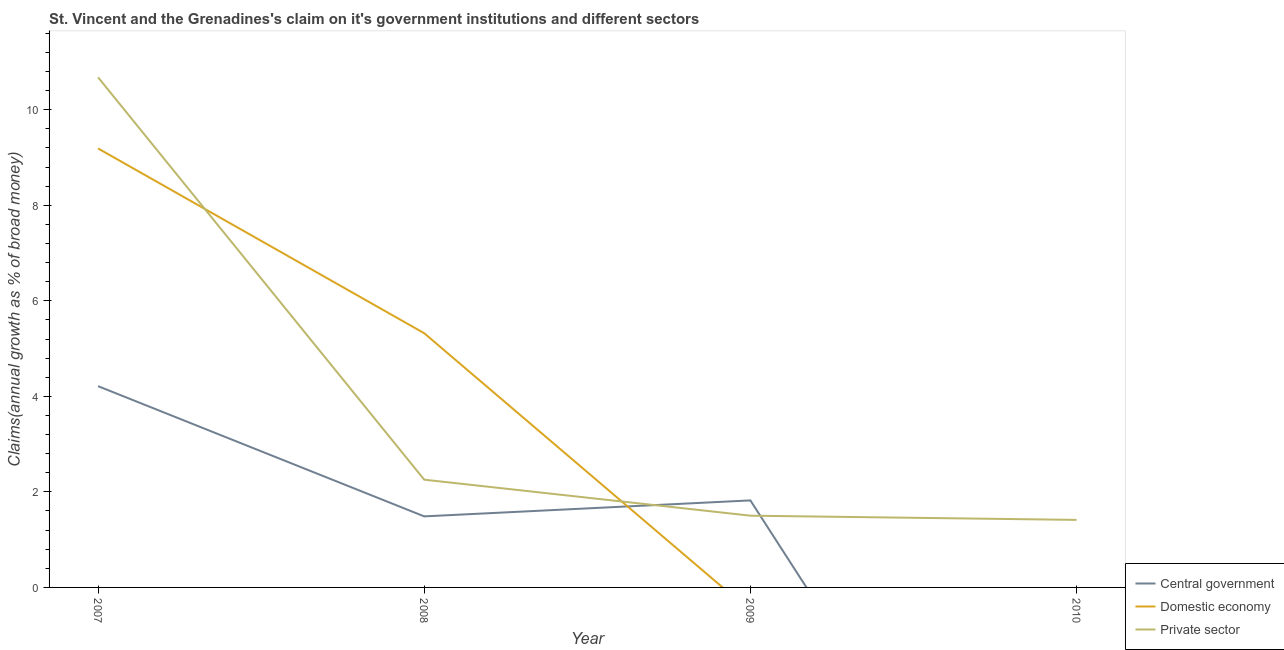How many different coloured lines are there?
Offer a very short reply. 3. Does the line corresponding to percentage of claim on the domestic economy intersect with the line corresponding to percentage of claim on the central government?
Keep it short and to the point. Yes. Is the number of lines equal to the number of legend labels?
Your answer should be very brief. No. What is the percentage of claim on the domestic economy in 2008?
Offer a very short reply. 5.32. Across all years, what is the maximum percentage of claim on the central government?
Make the answer very short. 4.21. What is the total percentage of claim on the central government in the graph?
Offer a very short reply. 7.52. What is the difference between the percentage of claim on the private sector in 2008 and that in 2009?
Offer a very short reply. 0.75. What is the difference between the percentage of claim on the central government in 2008 and the percentage of claim on the private sector in 2010?
Keep it short and to the point. 0.07. What is the average percentage of claim on the central government per year?
Keep it short and to the point. 1.88. In the year 2008, what is the difference between the percentage of claim on the central government and percentage of claim on the domestic economy?
Make the answer very short. -3.83. What is the ratio of the percentage of claim on the private sector in 2008 to that in 2010?
Ensure brevity in your answer.  1.6. Is the percentage of claim on the private sector in 2007 less than that in 2010?
Make the answer very short. No. Is the difference between the percentage of claim on the private sector in 2007 and 2008 greater than the difference between the percentage of claim on the central government in 2007 and 2008?
Your response must be concise. Yes. What is the difference between the highest and the second highest percentage of claim on the private sector?
Provide a succinct answer. 8.42. What is the difference between the highest and the lowest percentage of claim on the private sector?
Offer a very short reply. 9.26. In how many years, is the percentage of claim on the private sector greater than the average percentage of claim on the private sector taken over all years?
Make the answer very short. 1. Is it the case that in every year, the sum of the percentage of claim on the central government and percentage of claim on the domestic economy is greater than the percentage of claim on the private sector?
Your answer should be very brief. No. Does the percentage of claim on the central government monotonically increase over the years?
Offer a terse response. No. How many years are there in the graph?
Your answer should be compact. 4. How are the legend labels stacked?
Your response must be concise. Vertical. What is the title of the graph?
Give a very brief answer. St. Vincent and the Grenadines's claim on it's government institutions and different sectors. What is the label or title of the X-axis?
Your answer should be compact. Year. What is the label or title of the Y-axis?
Keep it short and to the point. Claims(annual growth as % of broad money). What is the Claims(annual growth as % of broad money) in Central government in 2007?
Offer a terse response. 4.21. What is the Claims(annual growth as % of broad money) in Domestic economy in 2007?
Your response must be concise. 9.19. What is the Claims(annual growth as % of broad money) of Private sector in 2007?
Provide a succinct answer. 10.68. What is the Claims(annual growth as % of broad money) of Central government in 2008?
Ensure brevity in your answer.  1.49. What is the Claims(annual growth as % of broad money) of Domestic economy in 2008?
Make the answer very short. 5.32. What is the Claims(annual growth as % of broad money) of Private sector in 2008?
Offer a terse response. 2.26. What is the Claims(annual growth as % of broad money) in Central government in 2009?
Your answer should be very brief. 1.82. What is the Claims(annual growth as % of broad money) of Domestic economy in 2009?
Ensure brevity in your answer.  0. What is the Claims(annual growth as % of broad money) in Private sector in 2009?
Your response must be concise. 1.5. What is the Claims(annual growth as % of broad money) in Private sector in 2010?
Your answer should be compact. 1.41. Across all years, what is the maximum Claims(annual growth as % of broad money) of Central government?
Your answer should be compact. 4.21. Across all years, what is the maximum Claims(annual growth as % of broad money) in Domestic economy?
Offer a very short reply. 9.19. Across all years, what is the maximum Claims(annual growth as % of broad money) of Private sector?
Provide a short and direct response. 10.68. Across all years, what is the minimum Claims(annual growth as % of broad money) of Central government?
Make the answer very short. 0. Across all years, what is the minimum Claims(annual growth as % of broad money) of Domestic economy?
Ensure brevity in your answer.  0. Across all years, what is the minimum Claims(annual growth as % of broad money) in Private sector?
Your response must be concise. 1.41. What is the total Claims(annual growth as % of broad money) in Central government in the graph?
Your response must be concise. 7.52. What is the total Claims(annual growth as % of broad money) of Domestic economy in the graph?
Ensure brevity in your answer.  14.51. What is the total Claims(annual growth as % of broad money) of Private sector in the graph?
Give a very brief answer. 15.85. What is the difference between the Claims(annual growth as % of broad money) in Central government in 2007 and that in 2008?
Offer a very short reply. 2.73. What is the difference between the Claims(annual growth as % of broad money) in Domestic economy in 2007 and that in 2008?
Make the answer very short. 3.87. What is the difference between the Claims(annual growth as % of broad money) of Private sector in 2007 and that in 2008?
Offer a terse response. 8.42. What is the difference between the Claims(annual growth as % of broad money) of Central government in 2007 and that in 2009?
Ensure brevity in your answer.  2.39. What is the difference between the Claims(annual growth as % of broad money) in Private sector in 2007 and that in 2009?
Offer a very short reply. 9.18. What is the difference between the Claims(annual growth as % of broad money) in Private sector in 2007 and that in 2010?
Your answer should be very brief. 9.26. What is the difference between the Claims(annual growth as % of broad money) of Central government in 2008 and that in 2009?
Ensure brevity in your answer.  -0.33. What is the difference between the Claims(annual growth as % of broad money) of Private sector in 2008 and that in 2009?
Make the answer very short. 0.75. What is the difference between the Claims(annual growth as % of broad money) of Private sector in 2008 and that in 2010?
Ensure brevity in your answer.  0.84. What is the difference between the Claims(annual growth as % of broad money) of Private sector in 2009 and that in 2010?
Provide a succinct answer. 0.09. What is the difference between the Claims(annual growth as % of broad money) in Central government in 2007 and the Claims(annual growth as % of broad money) in Domestic economy in 2008?
Give a very brief answer. -1.11. What is the difference between the Claims(annual growth as % of broad money) of Central government in 2007 and the Claims(annual growth as % of broad money) of Private sector in 2008?
Your response must be concise. 1.96. What is the difference between the Claims(annual growth as % of broad money) in Domestic economy in 2007 and the Claims(annual growth as % of broad money) in Private sector in 2008?
Make the answer very short. 6.93. What is the difference between the Claims(annual growth as % of broad money) of Central government in 2007 and the Claims(annual growth as % of broad money) of Private sector in 2009?
Your answer should be compact. 2.71. What is the difference between the Claims(annual growth as % of broad money) of Domestic economy in 2007 and the Claims(annual growth as % of broad money) of Private sector in 2009?
Your answer should be compact. 7.69. What is the difference between the Claims(annual growth as % of broad money) of Central government in 2007 and the Claims(annual growth as % of broad money) of Private sector in 2010?
Make the answer very short. 2.8. What is the difference between the Claims(annual growth as % of broad money) of Domestic economy in 2007 and the Claims(annual growth as % of broad money) of Private sector in 2010?
Offer a very short reply. 7.78. What is the difference between the Claims(annual growth as % of broad money) of Central government in 2008 and the Claims(annual growth as % of broad money) of Private sector in 2009?
Provide a succinct answer. -0.01. What is the difference between the Claims(annual growth as % of broad money) of Domestic economy in 2008 and the Claims(annual growth as % of broad money) of Private sector in 2009?
Give a very brief answer. 3.82. What is the difference between the Claims(annual growth as % of broad money) of Central government in 2008 and the Claims(annual growth as % of broad money) of Private sector in 2010?
Provide a short and direct response. 0.07. What is the difference between the Claims(annual growth as % of broad money) of Domestic economy in 2008 and the Claims(annual growth as % of broad money) of Private sector in 2010?
Provide a short and direct response. 3.91. What is the difference between the Claims(annual growth as % of broad money) of Central government in 2009 and the Claims(annual growth as % of broad money) of Private sector in 2010?
Offer a terse response. 0.41. What is the average Claims(annual growth as % of broad money) of Central government per year?
Your answer should be compact. 1.88. What is the average Claims(annual growth as % of broad money) of Domestic economy per year?
Provide a succinct answer. 3.63. What is the average Claims(annual growth as % of broad money) in Private sector per year?
Give a very brief answer. 3.96. In the year 2007, what is the difference between the Claims(annual growth as % of broad money) in Central government and Claims(annual growth as % of broad money) in Domestic economy?
Offer a very short reply. -4.98. In the year 2007, what is the difference between the Claims(annual growth as % of broad money) of Central government and Claims(annual growth as % of broad money) of Private sector?
Your response must be concise. -6.47. In the year 2007, what is the difference between the Claims(annual growth as % of broad money) in Domestic economy and Claims(annual growth as % of broad money) in Private sector?
Provide a succinct answer. -1.49. In the year 2008, what is the difference between the Claims(annual growth as % of broad money) of Central government and Claims(annual growth as % of broad money) of Domestic economy?
Your answer should be compact. -3.83. In the year 2008, what is the difference between the Claims(annual growth as % of broad money) of Central government and Claims(annual growth as % of broad money) of Private sector?
Make the answer very short. -0.77. In the year 2008, what is the difference between the Claims(annual growth as % of broad money) in Domestic economy and Claims(annual growth as % of broad money) in Private sector?
Provide a short and direct response. 3.07. In the year 2009, what is the difference between the Claims(annual growth as % of broad money) in Central government and Claims(annual growth as % of broad money) in Private sector?
Your response must be concise. 0.32. What is the ratio of the Claims(annual growth as % of broad money) in Central government in 2007 to that in 2008?
Offer a terse response. 2.83. What is the ratio of the Claims(annual growth as % of broad money) of Domestic economy in 2007 to that in 2008?
Offer a very short reply. 1.73. What is the ratio of the Claims(annual growth as % of broad money) in Private sector in 2007 to that in 2008?
Give a very brief answer. 4.73. What is the ratio of the Claims(annual growth as % of broad money) in Central government in 2007 to that in 2009?
Ensure brevity in your answer.  2.31. What is the ratio of the Claims(annual growth as % of broad money) in Private sector in 2007 to that in 2009?
Offer a very short reply. 7.11. What is the ratio of the Claims(annual growth as % of broad money) of Private sector in 2007 to that in 2010?
Offer a terse response. 7.55. What is the ratio of the Claims(annual growth as % of broad money) of Central government in 2008 to that in 2009?
Provide a succinct answer. 0.82. What is the ratio of the Claims(annual growth as % of broad money) of Private sector in 2008 to that in 2009?
Your answer should be very brief. 1.5. What is the ratio of the Claims(annual growth as % of broad money) in Private sector in 2008 to that in 2010?
Your answer should be very brief. 1.6. What is the ratio of the Claims(annual growth as % of broad money) of Private sector in 2009 to that in 2010?
Your response must be concise. 1.06. What is the difference between the highest and the second highest Claims(annual growth as % of broad money) in Central government?
Your answer should be compact. 2.39. What is the difference between the highest and the second highest Claims(annual growth as % of broad money) of Private sector?
Your answer should be compact. 8.42. What is the difference between the highest and the lowest Claims(annual growth as % of broad money) of Central government?
Your response must be concise. 4.21. What is the difference between the highest and the lowest Claims(annual growth as % of broad money) in Domestic economy?
Ensure brevity in your answer.  9.19. What is the difference between the highest and the lowest Claims(annual growth as % of broad money) of Private sector?
Provide a short and direct response. 9.26. 